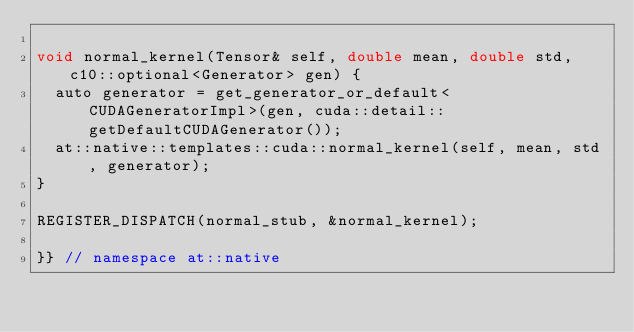Convert code to text. <code><loc_0><loc_0><loc_500><loc_500><_Cuda_>
void normal_kernel(Tensor& self, double mean, double std, c10::optional<Generator> gen) {
  auto generator = get_generator_or_default<CUDAGeneratorImpl>(gen, cuda::detail::getDefaultCUDAGenerator());
  at::native::templates::cuda::normal_kernel(self, mean, std, generator);
}

REGISTER_DISPATCH(normal_stub, &normal_kernel);

}} // namespace at::native
</code> 